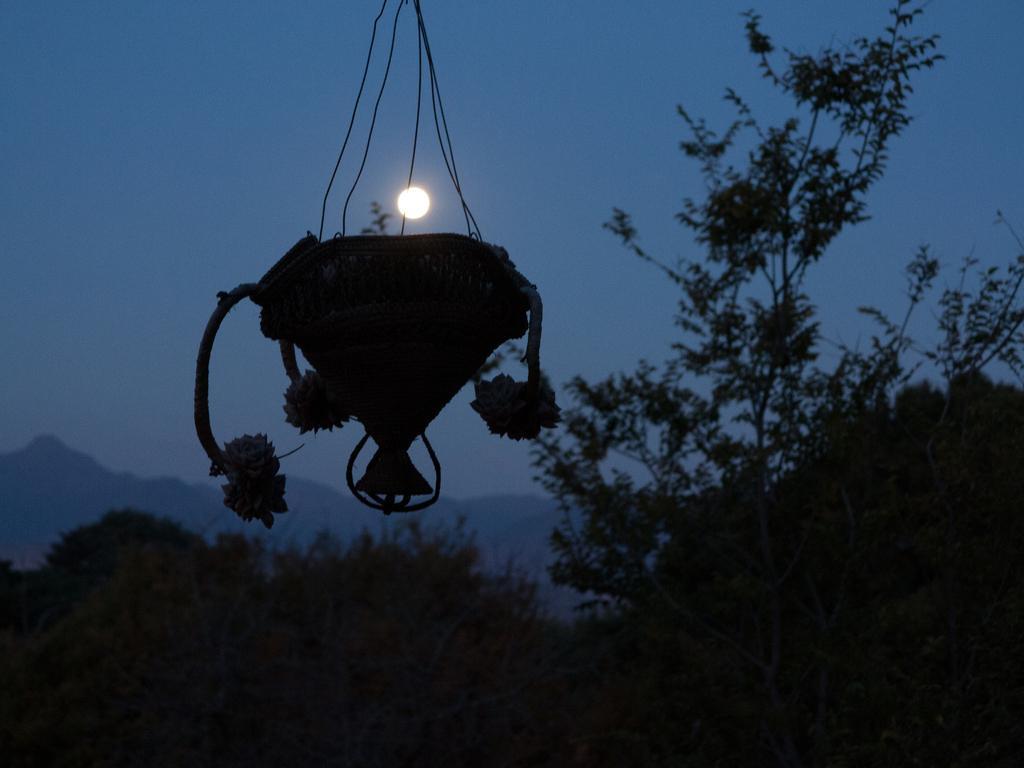Can you describe this image briefly? In this image there is a flower pot hanging and at the bottom of the image there are trees. In the background there are mountains and a sky. 